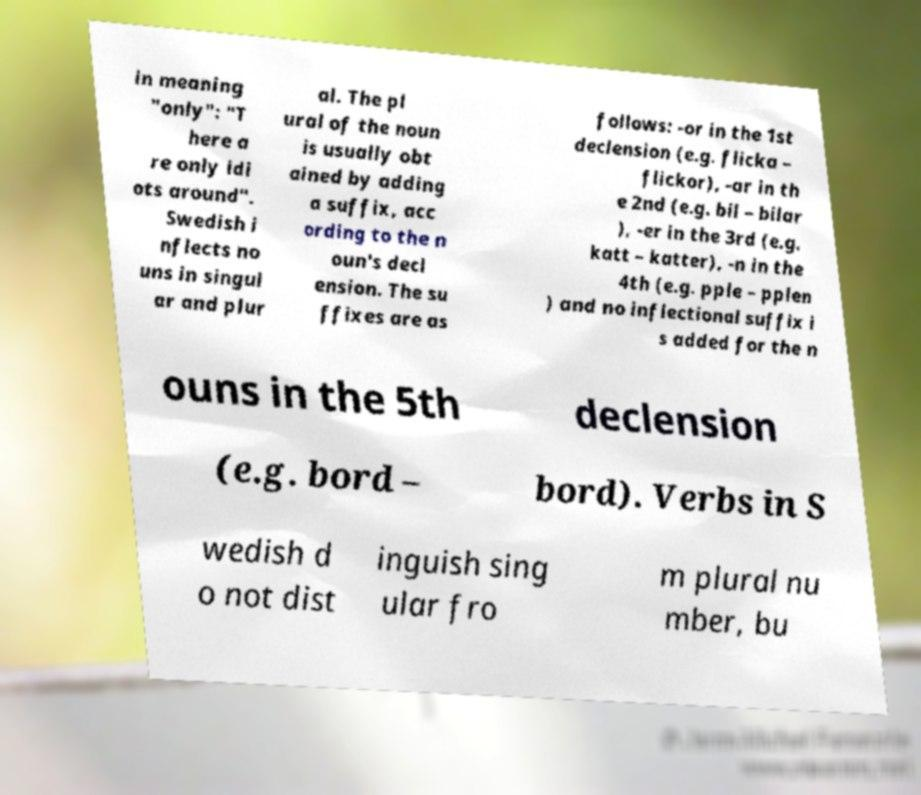Can you read and provide the text displayed in the image?This photo seems to have some interesting text. Can you extract and type it out for me? in meaning "only": "T here a re only idi ots around". Swedish i nflects no uns in singul ar and plur al. The pl ural of the noun is usually obt ained by adding a suffix, acc ording to the n oun's decl ension. The su ffixes are as follows: -or in the 1st declension (e.g. flicka – flickor), -ar in th e 2nd (e.g. bil – bilar ), -er in the 3rd (e.g. katt – katter), -n in the 4th (e.g. pple – pplen ) and no inflectional suffix i s added for the n ouns in the 5th declension (e.g. bord – bord). Verbs in S wedish d o not dist inguish sing ular fro m plural nu mber, bu 